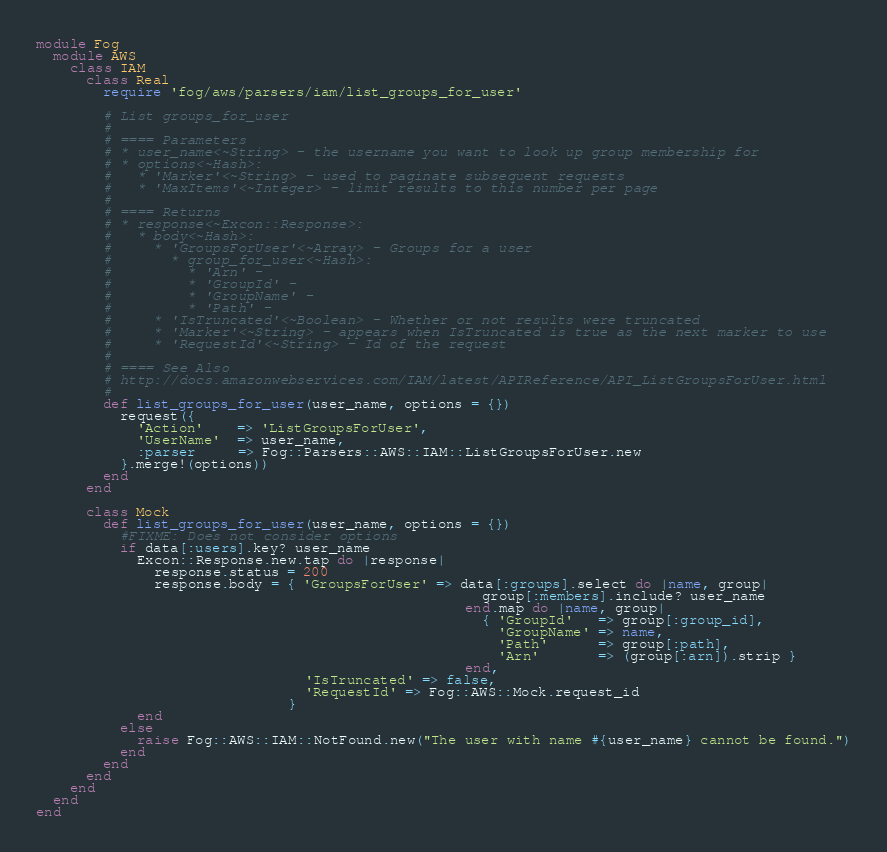<code> <loc_0><loc_0><loc_500><loc_500><_Ruby_>module Fog
  module AWS
    class IAM
      class Real
        require 'fog/aws/parsers/iam/list_groups_for_user'

        # List groups_for_user
        #
        # ==== Parameters
        # * user_name<~String> - the username you want to look up group membership for
        # * options<~Hash>:
        #   * 'Marker'<~String> - used to paginate subsequent requests
        #   * 'MaxItems'<~Integer> - limit results to this number per page
        #
        # ==== Returns
        # * response<~Excon::Response>:
        #   * body<~Hash>:
        #     * 'GroupsForUser'<~Array> - Groups for a user
        #       * group_for_user<~Hash>:
        #         * 'Arn' -
        #         * 'GroupId' -
        #         * 'GroupName' -
        #         * 'Path' -
        #     * 'IsTruncated'<~Boolean> - Whether or not results were truncated
        #     * 'Marker'<~String> - appears when IsTruncated is true as the next marker to use
        #     * 'RequestId'<~String> - Id of the request
        #
        # ==== See Also
        # http://docs.amazonwebservices.com/IAM/latest/APIReference/API_ListGroupsForUser.html
        #
        def list_groups_for_user(user_name, options = {})
          request({
            'Action'    => 'ListGroupsForUser',
            'UserName'  => user_name,
            :parser     => Fog::Parsers::AWS::IAM::ListGroupsForUser.new
          }.merge!(options))
        end
      end

      class Mock
        def list_groups_for_user(user_name, options = {})
          #FIXME: Does not consider options
          if data[:users].key? user_name
            Excon::Response.new.tap do |response|
              response.status = 200
              response.body = { 'GroupsForUser' => data[:groups].select do |name, group|
                                                     group[:members].include? user_name
                                                   end.map do |name, group|
                                                     { 'GroupId'   => group[:group_id],
                                                       'GroupName' => name,
                                                       'Path'      => group[:path],
                                                       'Arn'       => (group[:arn]).strip }
                                                   end,
                                'IsTruncated' => false,
                                'RequestId' => Fog::AWS::Mock.request_id
                              }
            end
          else
            raise Fog::AWS::IAM::NotFound.new("The user with name #{user_name} cannot be found.")
          end
        end
      end
    end
  end
end
</code> 